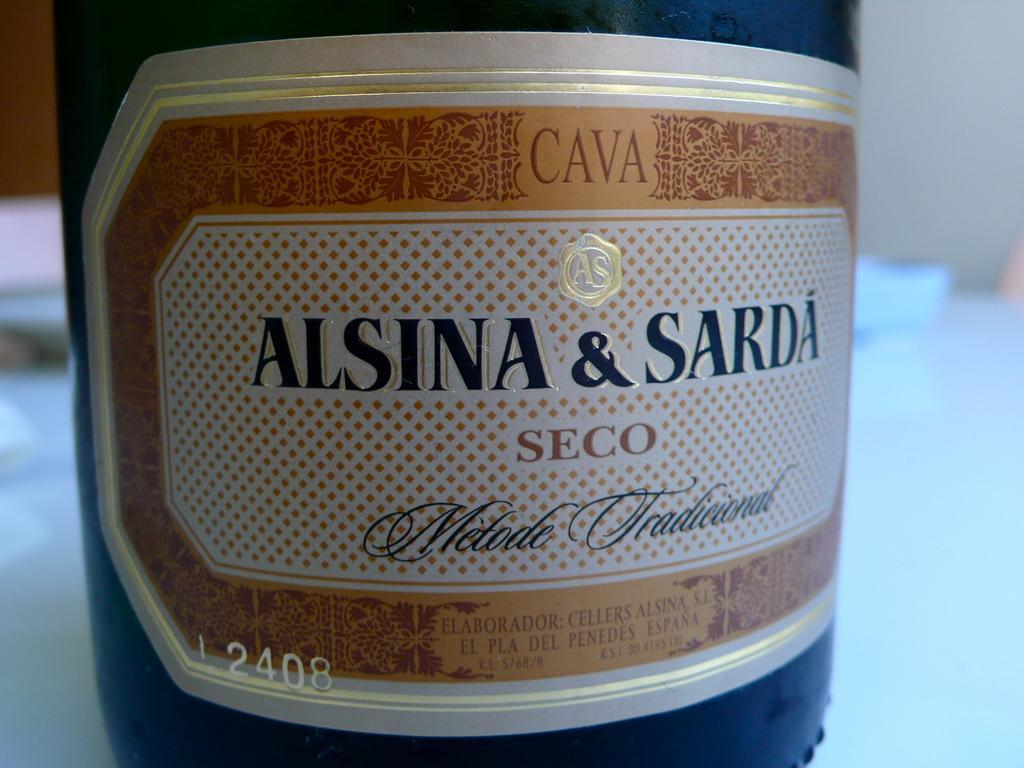Describe this image in one or two sentences. In this image, we can see a label on the bottle contains some text. In the background, image is blurred. 